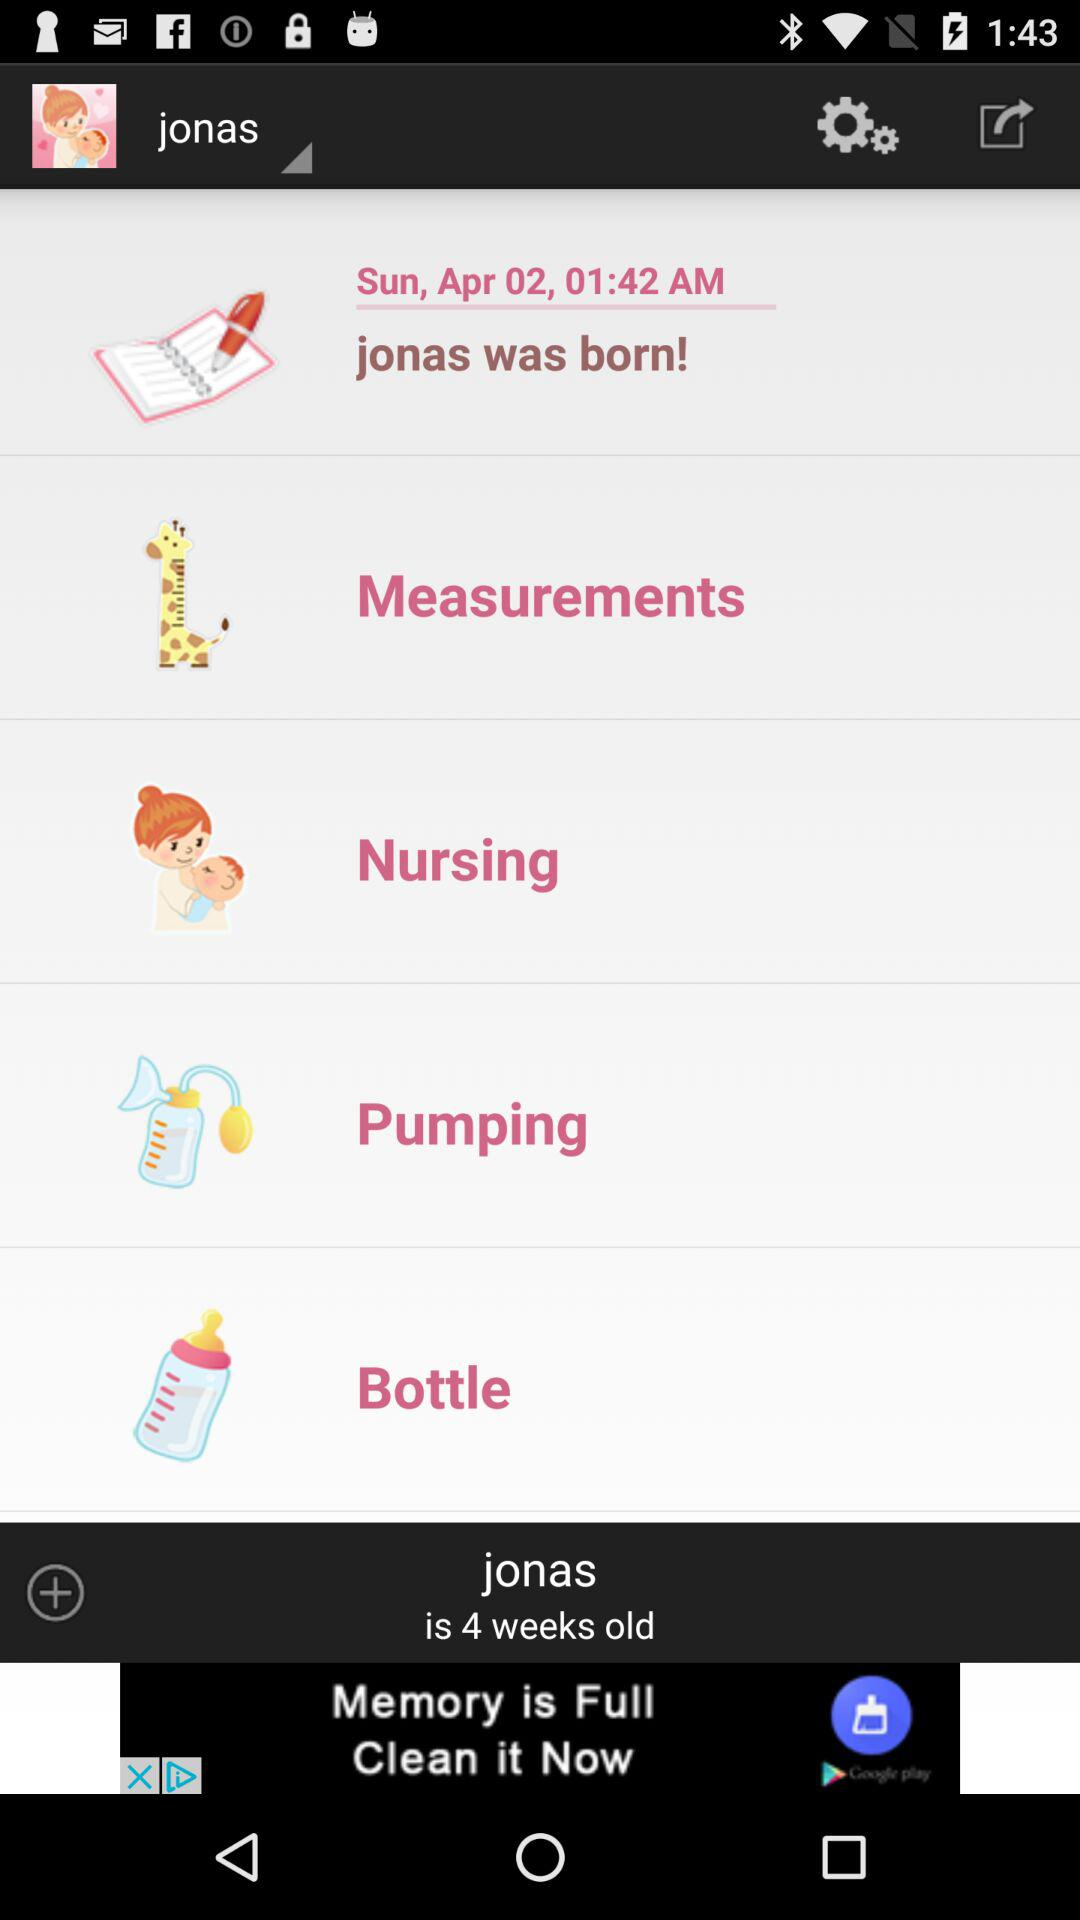What is the current age of Jonas? Jonas is 4 weeks old. 